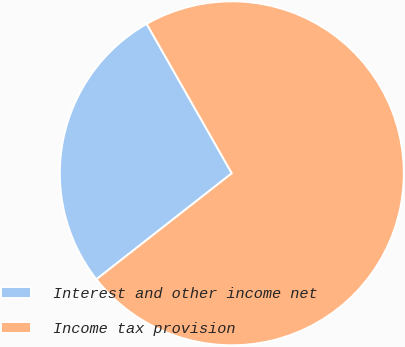<chart> <loc_0><loc_0><loc_500><loc_500><pie_chart><fcel>Interest and other income net<fcel>Income tax provision<nl><fcel>27.33%<fcel>72.67%<nl></chart> 